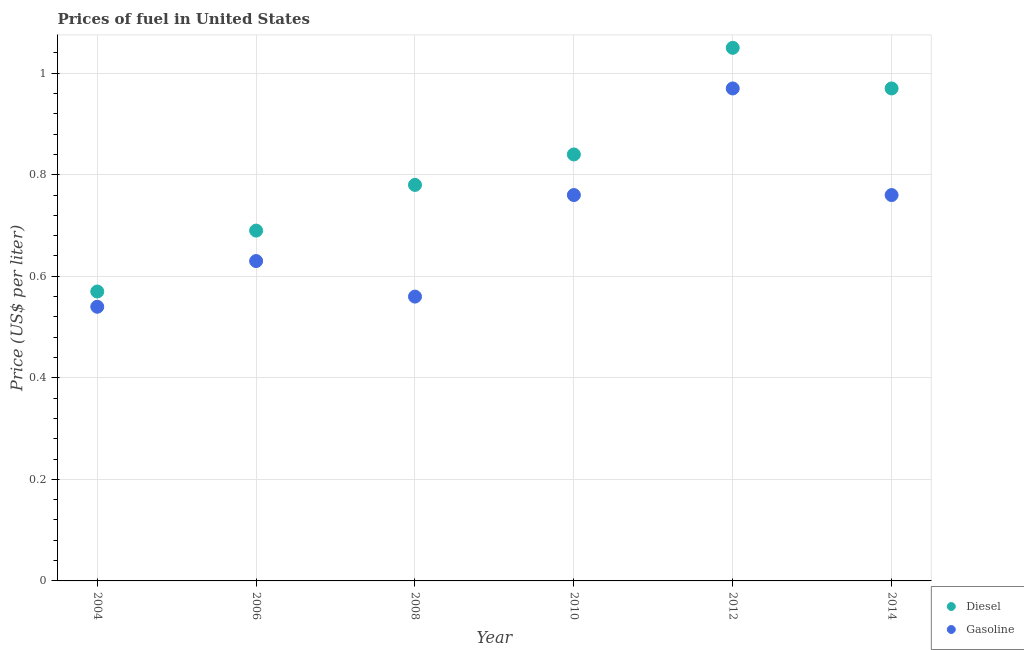What is the gasoline price in 2006?
Your answer should be compact. 0.63. Across all years, what is the maximum diesel price?
Offer a terse response. 1.05. Across all years, what is the minimum diesel price?
Make the answer very short. 0.57. What is the total diesel price in the graph?
Provide a succinct answer. 4.9. What is the difference between the diesel price in 2006 and that in 2010?
Offer a very short reply. -0.15. What is the difference between the gasoline price in 2010 and the diesel price in 2006?
Make the answer very short. 0.07. What is the average diesel price per year?
Make the answer very short. 0.82. In the year 2004, what is the difference between the diesel price and gasoline price?
Your response must be concise. 0.03. What is the ratio of the diesel price in 2012 to that in 2014?
Your answer should be compact. 1.08. Is the diesel price in 2006 less than that in 2012?
Offer a very short reply. Yes. Is the difference between the gasoline price in 2008 and 2012 greater than the difference between the diesel price in 2008 and 2012?
Provide a succinct answer. No. What is the difference between the highest and the second highest diesel price?
Ensure brevity in your answer.  0.08. What is the difference between the highest and the lowest diesel price?
Your response must be concise. 0.48. Is the sum of the gasoline price in 2010 and 2012 greater than the maximum diesel price across all years?
Your answer should be compact. Yes. Is the diesel price strictly less than the gasoline price over the years?
Make the answer very short. No. How many dotlines are there?
Offer a very short reply. 2. How many years are there in the graph?
Offer a terse response. 6. What is the difference between two consecutive major ticks on the Y-axis?
Keep it short and to the point. 0.2. Are the values on the major ticks of Y-axis written in scientific E-notation?
Your answer should be compact. No. How many legend labels are there?
Your answer should be compact. 2. How are the legend labels stacked?
Keep it short and to the point. Vertical. What is the title of the graph?
Provide a short and direct response. Prices of fuel in United States. Does "Investment" appear as one of the legend labels in the graph?
Ensure brevity in your answer.  No. What is the label or title of the Y-axis?
Provide a short and direct response. Price (US$ per liter). What is the Price (US$ per liter) of Diesel in 2004?
Your answer should be very brief. 0.57. What is the Price (US$ per liter) of Gasoline in 2004?
Provide a succinct answer. 0.54. What is the Price (US$ per liter) of Diesel in 2006?
Ensure brevity in your answer.  0.69. What is the Price (US$ per liter) of Gasoline in 2006?
Your answer should be very brief. 0.63. What is the Price (US$ per liter) in Diesel in 2008?
Keep it short and to the point. 0.78. What is the Price (US$ per liter) of Gasoline in 2008?
Ensure brevity in your answer.  0.56. What is the Price (US$ per liter) of Diesel in 2010?
Your answer should be very brief. 0.84. What is the Price (US$ per liter) in Gasoline in 2010?
Ensure brevity in your answer.  0.76. What is the Price (US$ per liter) in Diesel in 2012?
Provide a succinct answer. 1.05. What is the Price (US$ per liter) in Gasoline in 2012?
Keep it short and to the point. 0.97. What is the Price (US$ per liter) of Gasoline in 2014?
Keep it short and to the point. 0.76. Across all years, what is the maximum Price (US$ per liter) in Gasoline?
Offer a very short reply. 0.97. Across all years, what is the minimum Price (US$ per liter) in Diesel?
Make the answer very short. 0.57. Across all years, what is the minimum Price (US$ per liter) of Gasoline?
Keep it short and to the point. 0.54. What is the total Price (US$ per liter) in Diesel in the graph?
Your answer should be very brief. 4.9. What is the total Price (US$ per liter) in Gasoline in the graph?
Your response must be concise. 4.22. What is the difference between the Price (US$ per liter) in Diesel in 2004 and that in 2006?
Provide a short and direct response. -0.12. What is the difference between the Price (US$ per liter) in Gasoline in 2004 and that in 2006?
Your answer should be very brief. -0.09. What is the difference between the Price (US$ per liter) in Diesel in 2004 and that in 2008?
Offer a terse response. -0.21. What is the difference between the Price (US$ per liter) in Gasoline in 2004 and that in 2008?
Ensure brevity in your answer.  -0.02. What is the difference between the Price (US$ per liter) in Diesel in 2004 and that in 2010?
Offer a very short reply. -0.27. What is the difference between the Price (US$ per liter) of Gasoline in 2004 and that in 2010?
Make the answer very short. -0.22. What is the difference between the Price (US$ per liter) in Diesel in 2004 and that in 2012?
Make the answer very short. -0.48. What is the difference between the Price (US$ per liter) in Gasoline in 2004 and that in 2012?
Ensure brevity in your answer.  -0.43. What is the difference between the Price (US$ per liter) in Gasoline in 2004 and that in 2014?
Offer a very short reply. -0.22. What is the difference between the Price (US$ per liter) of Diesel in 2006 and that in 2008?
Keep it short and to the point. -0.09. What is the difference between the Price (US$ per liter) in Gasoline in 2006 and that in 2008?
Provide a succinct answer. 0.07. What is the difference between the Price (US$ per liter) in Diesel in 2006 and that in 2010?
Give a very brief answer. -0.15. What is the difference between the Price (US$ per liter) of Gasoline in 2006 and that in 2010?
Provide a succinct answer. -0.13. What is the difference between the Price (US$ per liter) in Diesel in 2006 and that in 2012?
Your answer should be compact. -0.36. What is the difference between the Price (US$ per liter) of Gasoline in 2006 and that in 2012?
Your response must be concise. -0.34. What is the difference between the Price (US$ per liter) in Diesel in 2006 and that in 2014?
Give a very brief answer. -0.28. What is the difference between the Price (US$ per liter) in Gasoline in 2006 and that in 2014?
Offer a very short reply. -0.13. What is the difference between the Price (US$ per liter) of Diesel in 2008 and that in 2010?
Ensure brevity in your answer.  -0.06. What is the difference between the Price (US$ per liter) of Gasoline in 2008 and that in 2010?
Keep it short and to the point. -0.2. What is the difference between the Price (US$ per liter) in Diesel in 2008 and that in 2012?
Offer a terse response. -0.27. What is the difference between the Price (US$ per liter) of Gasoline in 2008 and that in 2012?
Keep it short and to the point. -0.41. What is the difference between the Price (US$ per liter) of Diesel in 2008 and that in 2014?
Make the answer very short. -0.19. What is the difference between the Price (US$ per liter) of Diesel in 2010 and that in 2012?
Keep it short and to the point. -0.21. What is the difference between the Price (US$ per liter) in Gasoline in 2010 and that in 2012?
Offer a very short reply. -0.21. What is the difference between the Price (US$ per liter) of Diesel in 2010 and that in 2014?
Your response must be concise. -0.13. What is the difference between the Price (US$ per liter) in Gasoline in 2010 and that in 2014?
Your response must be concise. 0. What is the difference between the Price (US$ per liter) of Gasoline in 2012 and that in 2014?
Make the answer very short. 0.21. What is the difference between the Price (US$ per liter) in Diesel in 2004 and the Price (US$ per liter) in Gasoline in 2006?
Offer a very short reply. -0.06. What is the difference between the Price (US$ per liter) of Diesel in 2004 and the Price (US$ per liter) of Gasoline in 2010?
Your answer should be compact. -0.19. What is the difference between the Price (US$ per liter) in Diesel in 2004 and the Price (US$ per liter) in Gasoline in 2014?
Make the answer very short. -0.19. What is the difference between the Price (US$ per liter) of Diesel in 2006 and the Price (US$ per liter) of Gasoline in 2008?
Keep it short and to the point. 0.13. What is the difference between the Price (US$ per liter) in Diesel in 2006 and the Price (US$ per liter) in Gasoline in 2010?
Ensure brevity in your answer.  -0.07. What is the difference between the Price (US$ per liter) in Diesel in 2006 and the Price (US$ per liter) in Gasoline in 2012?
Provide a succinct answer. -0.28. What is the difference between the Price (US$ per liter) of Diesel in 2006 and the Price (US$ per liter) of Gasoline in 2014?
Ensure brevity in your answer.  -0.07. What is the difference between the Price (US$ per liter) of Diesel in 2008 and the Price (US$ per liter) of Gasoline in 2010?
Make the answer very short. 0.02. What is the difference between the Price (US$ per liter) of Diesel in 2008 and the Price (US$ per liter) of Gasoline in 2012?
Offer a terse response. -0.19. What is the difference between the Price (US$ per liter) of Diesel in 2010 and the Price (US$ per liter) of Gasoline in 2012?
Make the answer very short. -0.13. What is the difference between the Price (US$ per liter) of Diesel in 2010 and the Price (US$ per liter) of Gasoline in 2014?
Offer a very short reply. 0.08. What is the difference between the Price (US$ per liter) in Diesel in 2012 and the Price (US$ per liter) in Gasoline in 2014?
Make the answer very short. 0.29. What is the average Price (US$ per liter) of Diesel per year?
Keep it short and to the point. 0.82. What is the average Price (US$ per liter) of Gasoline per year?
Give a very brief answer. 0.7. In the year 2008, what is the difference between the Price (US$ per liter) of Diesel and Price (US$ per liter) of Gasoline?
Provide a succinct answer. 0.22. In the year 2010, what is the difference between the Price (US$ per liter) in Diesel and Price (US$ per liter) in Gasoline?
Provide a succinct answer. 0.08. In the year 2012, what is the difference between the Price (US$ per liter) of Diesel and Price (US$ per liter) of Gasoline?
Offer a very short reply. 0.08. In the year 2014, what is the difference between the Price (US$ per liter) of Diesel and Price (US$ per liter) of Gasoline?
Provide a succinct answer. 0.21. What is the ratio of the Price (US$ per liter) of Diesel in 2004 to that in 2006?
Provide a succinct answer. 0.83. What is the ratio of the Price (US$ per liter) of Diesel in 2004 to that in 2008?
Provide a short and direct response. 0.73. What is the ratio of the Price (US$ per liter) of Diesel in 2004 to that in 2010?
Offer a terse response. 0.68. What is the ratio of the Price (US$ per liter) of Gasoline in 2004 to that in 2010?
Keep it short and to the point. 0.71. What is the ratio of the Price (US$ per liter) of Diesel in 2004 to that in 2012?
Your answer should be compact. 0.54. What is the ratio of the Price (US$ per liter) of Gasoline in 2004 to that in 2012?
Your response must be concise. 0.56. What is the ratio of the Price (US$ per liter) in Diesel in 2004 to that in 2014?
Offer a very short reply. 0.59. What is the ratio of the Price (US$ per liter) of Gasoline in 2004 to that in 2014?
Your answer should be very brief. 0.71. What is the ratio of the Price (US$ per liter) of Diesel in 2006 to that in 2008?
Provide a short and direct response. 0.88. What is the ratio of the Price (US$ per liter) of Gasoline in 2006 to that in 2008?
Offer a terse response. 1.12. What is the ratio of the Price (US$ per liter) of Diesel in 2006 to that in 2010?
Keep it short and to the point. 0.82. What is the ratio of the Price (US$ per liter) of Gasoline in 2006 to that in 2010?
Your answer should be compact. 0.83. What is the ratio of the Price (US$ per liter) in Diesel in 2006 to that in 2012?
Your answer should be very brief. 0.66. What is the ratio of the Price (US$ per liter) of Gasoline in 2006 to that in 2012?
Give a very brief answer. 0.65. What is the ratio of the Price (US$ per liter) of Diesel in 2006 to that in 2014?
Give a very brief answer. 0.71. What is the ratio of the Price (US$ per liter) in Gasoline in 2006 to that in 2014?
Your answer should be compact. 0.83. What is the ratio of the Price (US$ per liter) in Gasoline in 2008 to that in 2010?
Ensure brevity in your answer.  0.74. What is the ratio of the Price (US$ per liter) of Diesel in 2008 to that in 2012?
Offer a very short reply. 0.74. What is the ratio of the Price (US$ per liter) in Gasoline in 2008 to that in 2012?
Ensure brevity in your answer.  0.58. What is the ratio of the Price (US$ per liter) in Diesel in 2008 to that in 2014?
Ensure brevity in your answer.  0.8. What is the ratio of the Price (US$ per liter) of Gasoline in 2008 to that in 2014?
Provide a short and direct response. 0.74. What is the ratio of the Price (US$ per liter) in Diesel in 2010 to that in 2012?
Your answer should be compact. 0.8. What is the ratio of the Price (US$ per liter) in Gasoline in 2010 to that in 2012?
Ensure brevity in your answer.  0.78. What is the ratio of the Price (US$ per liter) of Diesel in 2010 to that in 2014?
Offer a very short reply. 0.87. What is the ratio of the Price (US$ per liter) of Diesel in 2012 to that in 2014?
Your answer should be compact. 1.08. What is the ratio of the Price (US$ per liter) in Gasoline in 2012 to that in 2014?
Your answer should be very brief. 1.28. What is the difference between the highest and the second highest Price (US$ per liter) of Diesel?
Make the answer very short. 0.08. What is the difference between the highest and the second highest Price (US$ per liter) of Gasoline?
Ensure brevity in your answer.  0.21. What is the difference between the highest and the lowest Price (US$ per liter) of Diesel?
Keep it short and to the point. 0.48. What is the difference between the highest and the lowest Price (US$ per liter) in Gasoline?
Offer a terse response. 0.43. 